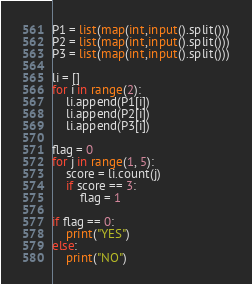<code> <loc_0><loc_0><loc_500><loc_500><_Python_>P1 = list(map(int,input().split()))
P2 = list(map(int,input().split()))
P3 = list(map(int,input().split()))

li = []
for i in range(2):
    li.append(P1[i])
    li.append(P2[i])
    li.append(P3[i])

flag = 0
for j in range(1, 5):
    score = li.count(j)
    if score == 3:
        flag = 1

if flag == 0:
    print("YES")
else:
    print("NO")</code> 